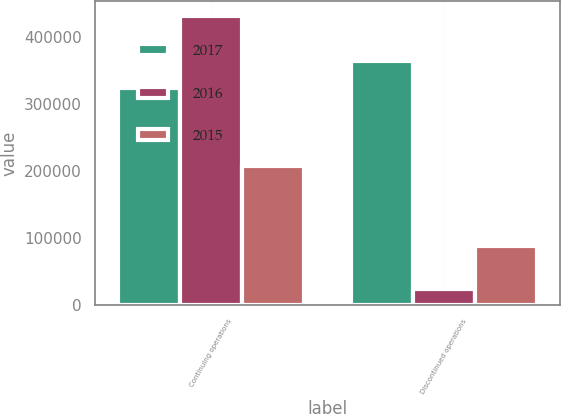Convert chart. <chart><loc_0><loc_0><loc_500><loc_500><stacked_bar_chart><ecel><fcel>Continuing operations<fcel>Discontinued operations<nl><fcel>2017<fcel>323859<fcel>364856<nl><fcel>2016<fcel>431761<fcel>24052<nl><fcel>2015<fcel>207510<fcel>88216<nl></chart> 